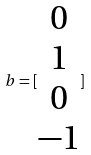<formula> <loc_0><loc_0><loc_500><loc_500>b = [ \begin{matrix} 0 \\ 1 \\ 0 \\ - 1 \end{matrix} ]</formula> 